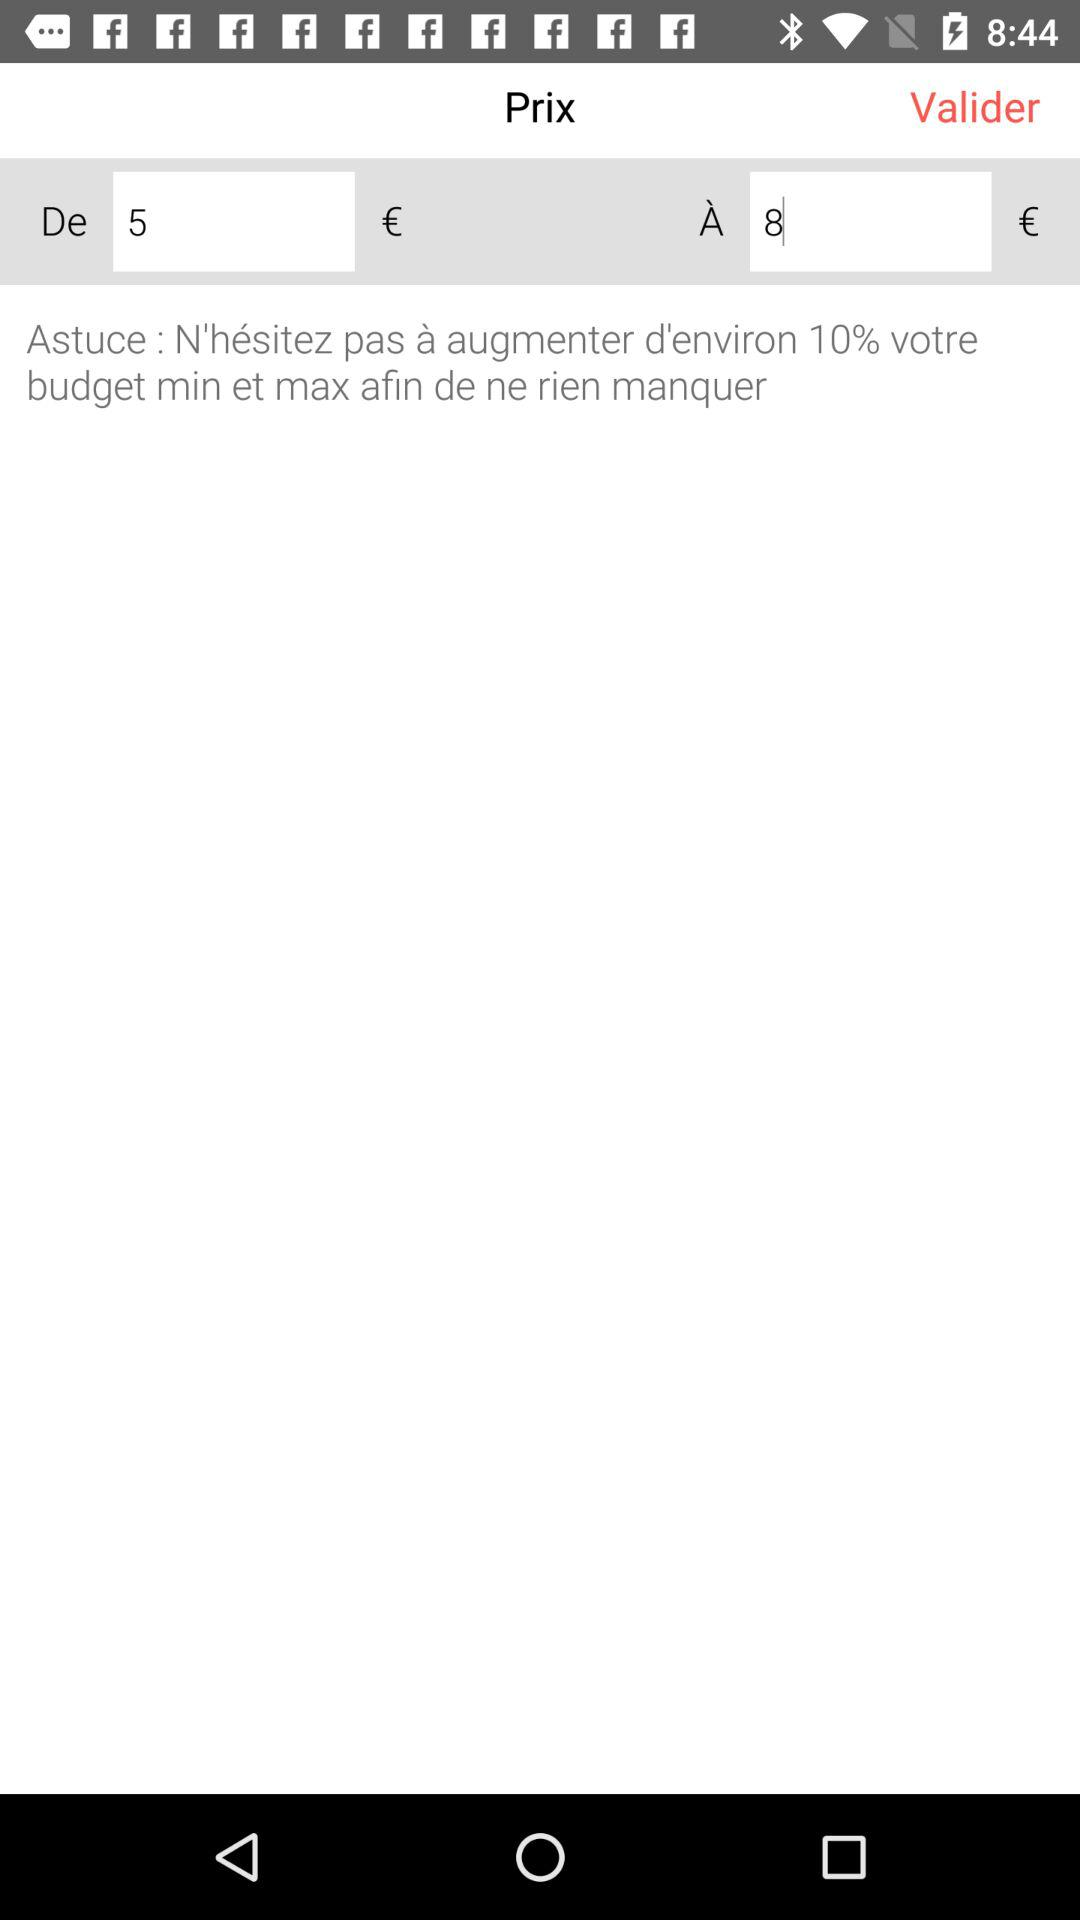What is the difference between the minimum and maximum prices?
Answer the question using a single word or phrase. 3 